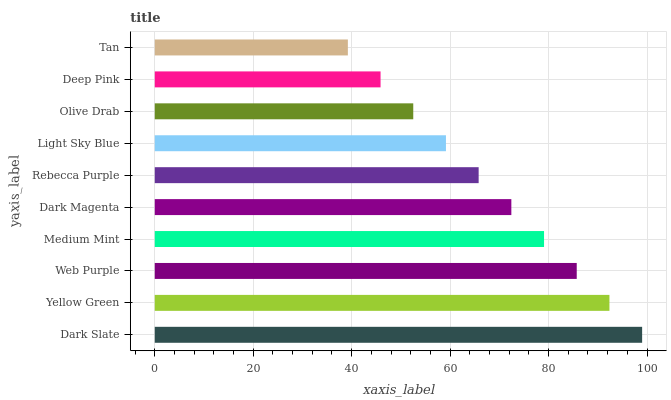Is Tan the minimum?
Answer yes or no. Yes. Is Dark Slate the maximum?
Answer yes or no. Yes. Is Yellow Green the minimum?
Answer yes or no. No. Is Yellow Green the maximum?
Answer yes or no. No. Is Dark Slate greater than Yellow Green?
Answer yes or no. Yes. Is Yellow Green less than Dark Slate?
Answer yes or no. Yes. Is Yellow Green greater than Dark Slate?
Answer yes or no. No. Is Dark Slate less than Yellow Green?
Answer yes or no. No. Is Dark Magenta the high median?
Answer yes or no. Yes. Is Rebecca Purple the low median?
Answer yes or no. Yes. Is Dark Slate the high median?
Answer yes or no. No. Is Tan the low median?
Answer yes or no. No. 